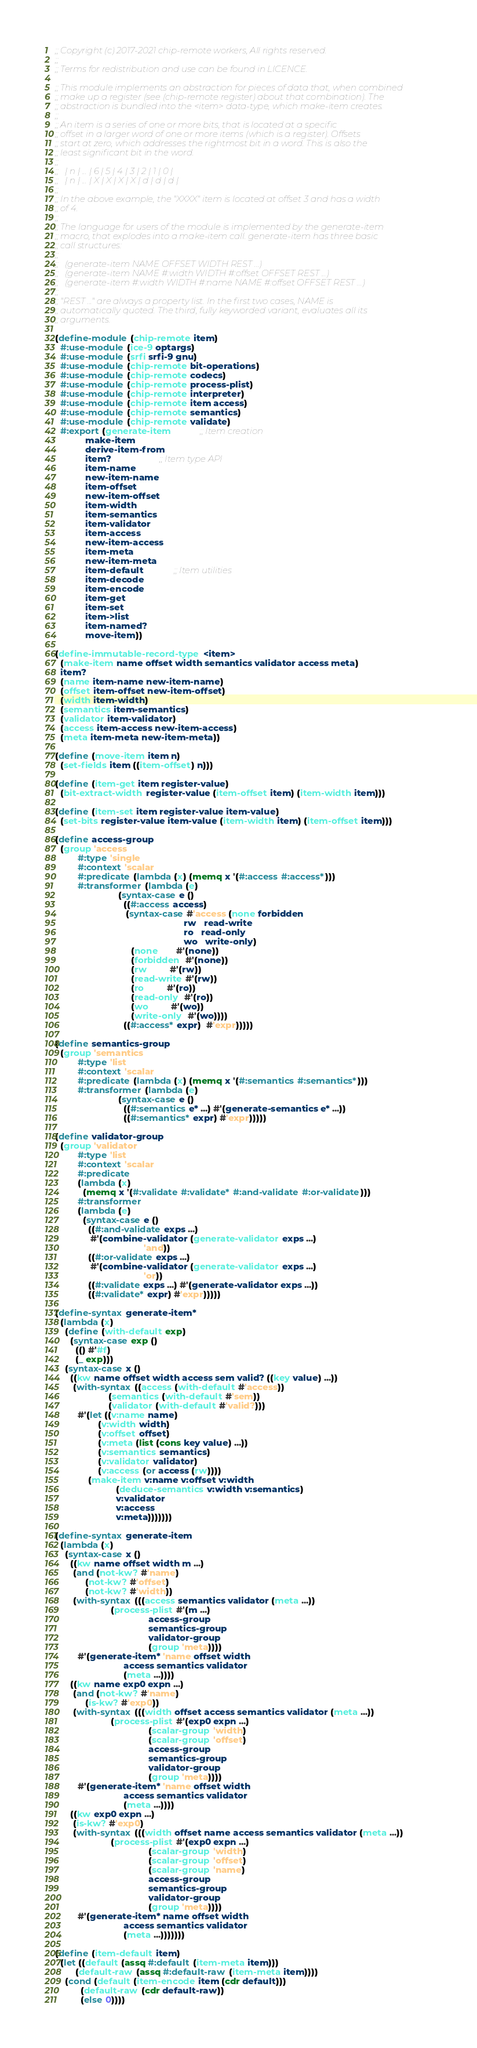<code> <loc_0><loc_0><loc_500><loc_500><_Scheme_>;; Copyright (c) 2017-2021 chip-remote workers, All rights reserved.
;;
;; Terms for redistribution and use can be found in LICENCE.

;; This module implements an abstraction for pieces of data that, when combined
;; make up a register (see (chip-remote register) about that combination). The
;; abstraction is bundled into the <item> data-type, which make-item creates.
;;
;; An item is a series of one or more bits, that is located at a specific
;; offset in a larger word of one or more items (which is a register). Offsets
;; start at zero, which addresses the rightmost bit in a word. This is also the
;; least significant bit in the word.
;;
;;   | n | ... | 6 | 5 | 4 | 3 | 2 | 1 | 0 |
;;   | n | ... | X | X | X | X | d | d | d |
;;
;; In the above example, the "XXXX" item is located at offset 3 and has a width
;; of 4.
;;
;; The language for users of the module is implemented by the generate-item
;; macro, that explodes into a make-item call. generate-item has three basic
;; call structures:
;;
;;   (generate-item NAME OFFSET WIDTH REST ...)
;;   (generate-item NAME #:width WIDTH #:offset OFFSET REST ...)
;;   (generate-item #:width WIDTH #:name NAME #:offset OFFSET REST ...)
;;
;; "REST ..." are always a property list. In the first two cases, NAME is
;; automatically quoted. The third, fully keyworded variant, evaluates all its
;; arguments.

(define-module (chip-remote item)
  #:use-module (ice-9 optargs)
  #:use-module (srfi srfi-9 gnu)
  #:use-module (chip-remote bit-operations)
  #:use-module (chip-remote codecs)
  #:use-module (chip-remote process-plist)
  #:use-module (chip-remote interpreter)
  #:use-module (chip-remote item access)
  #:use-module (chip-remote semantics)
  #:use-module (chip-remote validate)
  #:export (generate-item           ;; Item creation
            make-item
            derive-item-from
            item?                   ;; Item type API
            item-name
            new-item-name
            item-offset
            new-item-offset
            item-width
            item-semantics
            item-validator
            item-access
            new-item-access
            item-meta
            new-item-meta
            item-default            ;; Item utilities
            item-decode
            item-encode
            item-get
            item-set
            item->list
            item-named?
            move-item))

(define-immutable-record-type <item>
  (make-item name offset width semantics validator access meta)
  item?
  (name item-name new-item-name)
  (offset item-offset new-item-offset)
  (width item-width)
  (semantics item-semantics)
  (validator item-validator)
  (access item-access new-item-access)
  (meta item-meta new-item-meta))

(define (move-item item n)
  (set-fields item ((item-offset) n)))

(define (item-get item register-value)
  (bit-extract-width register-value (item-offset item) (item-width item)))

(define (item-set item register-value item-value)
  (set-bits register-value item-value (item-width item) (item-offset item)))

(define access-group
  (group 'access
         #:type 'single
         #:context 'scalar
         #:predicate (lambda (x) (memq x '(#:access #:access*)))
         #:transformer (lambda (e)
                         (syntax-case e ()
                           ((#:access access)
                            (syntax-case #'access (none forbidden
                                                   rw   read-write
                                                   ro   read-only
                                                   wo   write-only)
                              (none       #'(none))
                              (forbidden  #'(none))
                              (rw         #'(rw))
                              (read-write #'(rw))
                              (ro         #'(ro))
                              (read-only  #'(ro))
                              (wo         #'(wo))
                              (write-only  #'(wo))))
                           ((#:access* expr)  #'expr)))))

(define semantics-group
  (group 'semantics
         #:type 'list
         #:context 'scalar
         #:predicate (lambda (x) (memq x '(#:semantics #:semantics*)))
         #:transformer (lambda (e)
                         (syntax-case e ()
                           ((#:semantics e* ...) #'(generate-semantics e* ...))
                           ((#:semantics* expr) #'expr)))))

(define validator-group
  (group 'validator
         #:type 'list
         #:context 'scalar
         #:predicate
         (lambda (x)
           (memq x '(#:validate #:validate* #:and-validate #:or-validate)))
         #:transformer
         (lambda (e)
           (syntax-case e ()
             ((#:and-validate exps ...)
              #'(combine-validator (generate-validator exps ...)
                                   'and))
             ((#:or-validate exps ...)
              #'(combine-validator (generate-validator exps ...)
                                   'or))
             ((#:validate exps ...) #'(generate-validator exps ...))
             ((#:validate* expr) #'expr)))))

(define-syntax generate-item*
  (lambda (x)
    (define (with-default exp)
      (syntax-case exp ()
        (() #'#f)
        (_ exp)))
    (syntax-case x ()
      ((kw name offset width access sem valid? ((key value) ...))
       (with-syntax ((access (with-default #'access))
                     (semantics (with-default #'sem))
                     (validator (with-default #'valid?)))
         #'(let ((v:name name)
                 (v:width width)
                 (v:offset offset)
                 (v:meta (list (cons key value) ...))
                 (v:semantics semantics)
                 (v:validator validator)
                 (v:access (or access (rw))))
             (make-item v:name v:offset v:width
                        (deduce-semantics v:width v:semantics)
                        v:validator
                        v:access
                        v:meta)))))))

(define-syntax generate-item
  (lambda (x)
    (syntax-case x ()
      ((kw name offset width m ...)
       (and (not-kw? #'name)
            (not-kw? #'offset)
            (not-kw? #'width))
       (with-syntax (((access semantics validator (meta ...))
                      (process-plist #'(m ...)
                                     access-group
                                     semantics-group
                                     validator-group
                                     (group 'meta))))
         #'(generate-item* 'name offset width
                           access semantics validator
                           (meta ...))))
      ((kw name exp0 expn ...)
       (and (not-kw? #'name)
            (is-kw? #'exp0))
       (with-syntax (((width offset access semantics validator (meta ...))
                      (process-plist #'(exp0 expn ...)
                                     (scalar-group 'width)
                                     (scalar-group 'offset)
                                     access-group
                                     semantics-group
                                     validator-group
                                     (group 'meta))))
         #'(generate-item* 'name offset width
                           access semantics validator
                           (meta ...))))
      ((kw exp0 expn ...)
       (is-kw? #'exp0)
       (with-syntax (((width offset name access semantics validator (meta ...))
                      (process-plist #'(exp0 expn ...)
                                     (scalar-group 'width)
                                     (scalar-group 'offset)
                                     (scalar-group 'name)
                                     access-group
                                     semantics-group
                                     validator-group
                                     (group 'meta))))
         #'(generate-item* name offset width
                           access semantics validator
                           (meta ...)))))))

(define (item-default item)
  (let ((default (assq #:default (item-meta item)))
        (default-raw (assq #:default-raw (item-meta item))))
    (cond (default (item-encode item (cdr default)))
          (default-raw (cdr default-raw))
          (else 0))))
</code> 